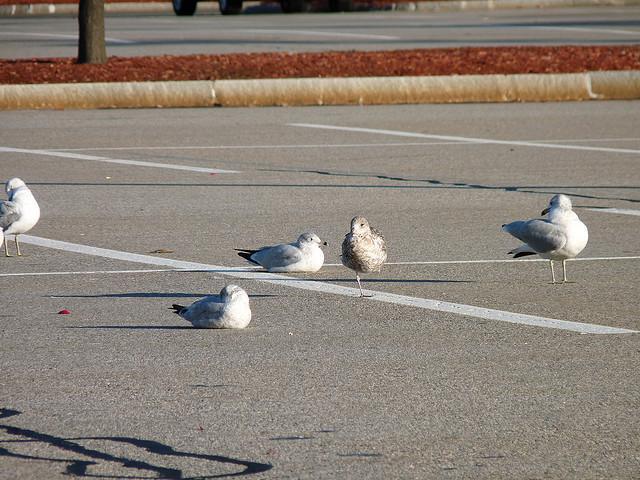How many birds are there in the picture?
Give a very brief answer. 5. How many bird legs can you see in this picture?
Give a very brief answer. 5. How many birds can you see?
Give a very brief answer. 4. 